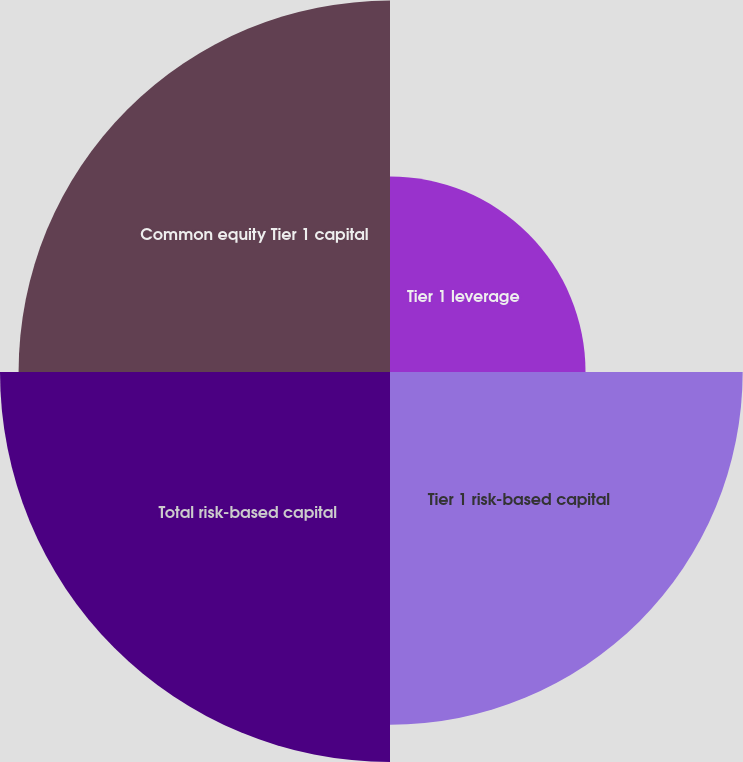<chart> <loc_0><loc_0><loc_500><loc_500><pie_chart><fcel>Tier 1 leverage<fcel>Tier 1 risk-based capital<fcel>Total risk-based capital<fcel>Common equity Tier 1 capital<nl><fcel>14.93%<fcel>26.93%<fcel>29.78%<fcel>28.36%<nl></chart> 